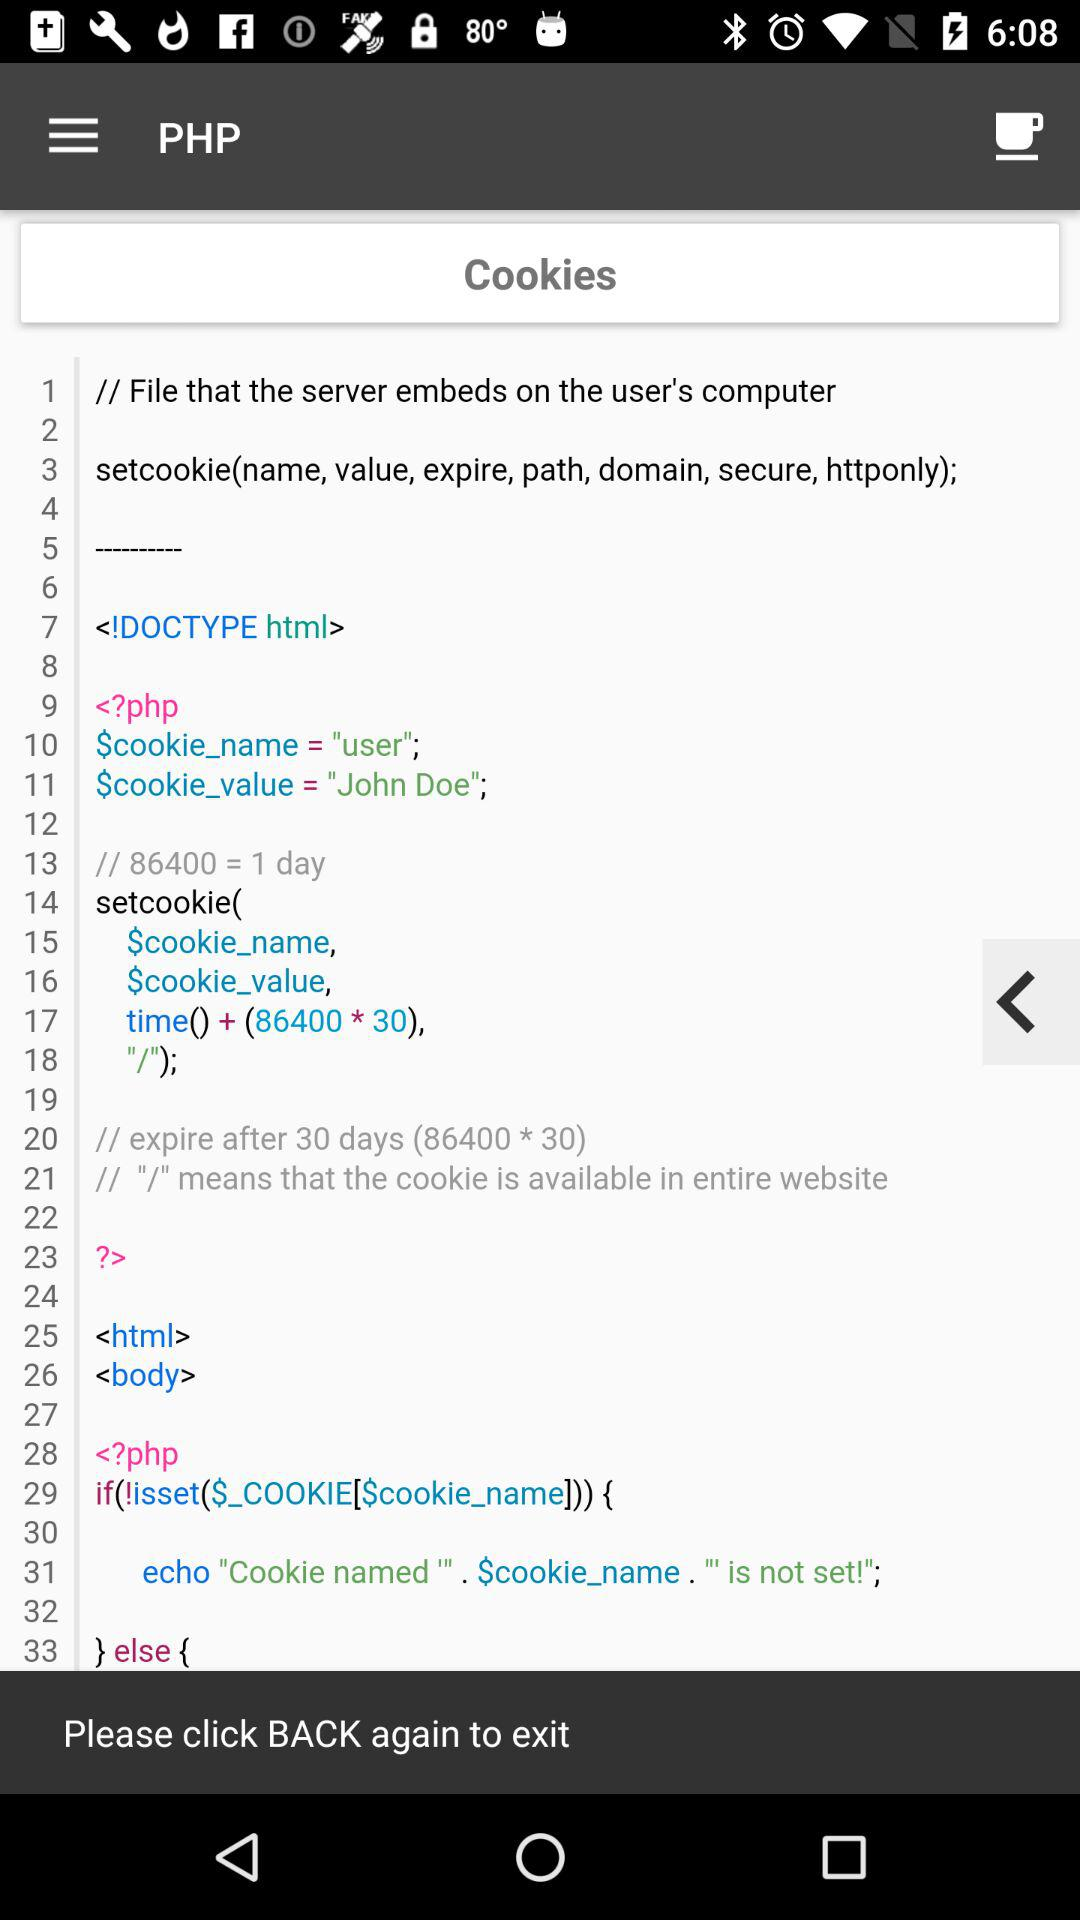What is the user's name?
When the provided information is insufficient, respond with <no answer>. <no answer> 